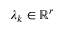<formula> <loc_0><loc_0><loc_500><loc_500>\lambda _ { k } \in \mathbb { R } ^ { r }</formula> 